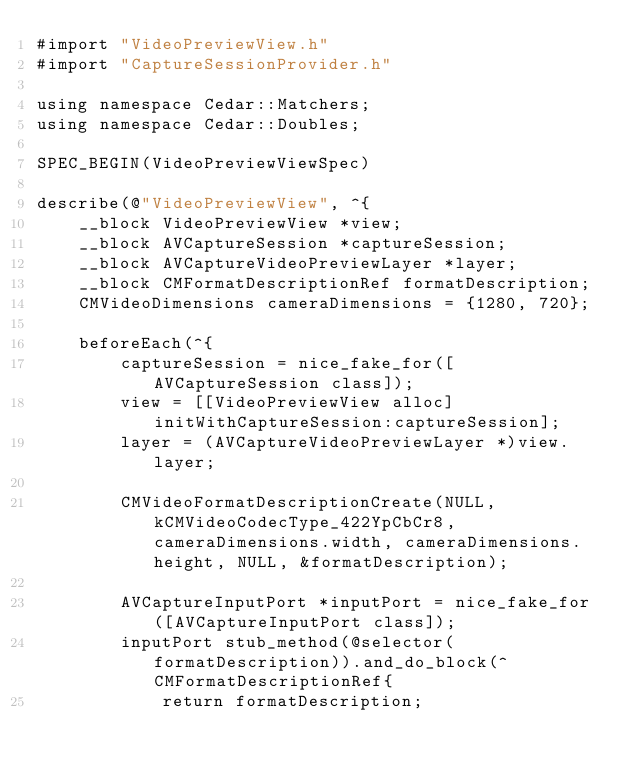<code> <loc_0><loc_0><loc_500><loc_500><_ObjectiveC_>#import "VideoPreviewView.h"
#import "CaptureSessionProvider.h"

using namespace Cedar::Matchers;
using namespace Cedar::Doubles;

SPEC_BEGIN(VideoPreviewViewSpec)

describe(@"VideoPreviewView", ^{
    __block VideoPreviewView *view;
    __block AVCaptureSession *captureSession;
    __block AVCaptureVideoPreviewLayer *layer;
    __block CMFormatDescriptionRef formatDescription;
    CMVideoDimensions cameraDimensions = {1280, 720};

    beforeEach(^{
        captureSession = nice_fake_for([AVCaptureSession class]);
        view = [[VideoPreviewView alloc] initWithCaptureSession:captureSession];
        layer = (AVCaptureVideoPreviewLayer *)view.layer;

        CMVideoFormatDescriptionCreate(NULL, kCMVideoCodecType_422YpCbCr8, cameraDimensions.width, cameraDimensions.height, NULL, &formatDescription);

        AVCaptureInputPort *inputPort = nice_fake_for([AVCaptureInputPort class]);
        inputPort stub_method(@selector(formatDescription)).and_do_block(^CMFormatDescriptionRef{
            return formatDescription;</code> 